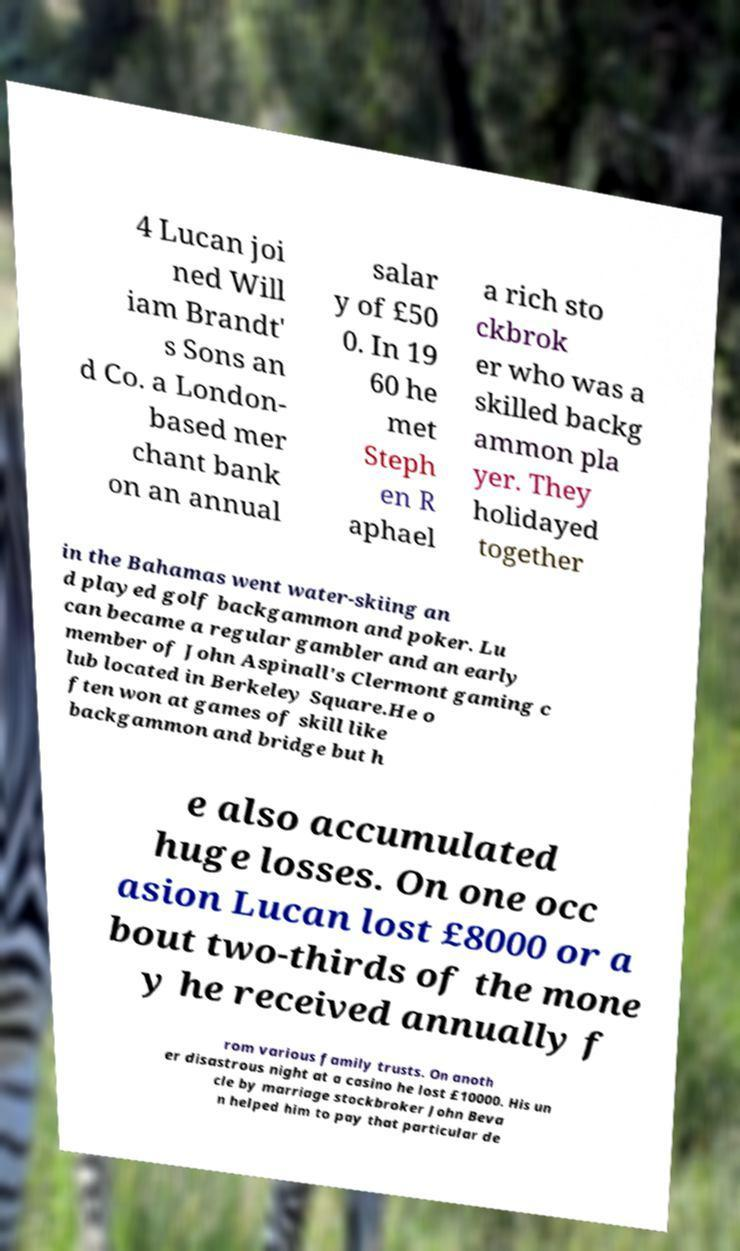What messages or text are displayed in this image? I need them in a readable, typed format. 4 Lucan joi ned Will iam Brandt' s Sons an d Co. a London- based mer chant bank on an annual salar y of £50 0. In 19 60 he met Steph en R aphael a rich sto ckbrok er who was a skilled backg ammon pla yer. They holidayed together in the Bahamas went water-skiing an d played golf backgammon and poker. Lu can became a regular gambler and an early member of John Aspinall's Clermont gaming c lub located in Berkeley Square.He o ften won at games of skill like backgammon and bridge but h e also accumulated huge losses. On one occ asion Lucan lost £8000 or a bout two-thirds of the mone y he received annually f rom various family trusts. On anoth er disastrous night at a casino he lost £10000. His un cle by marriage stockbroker John Beva n helped him to pay that particular de 